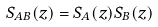<formula> <loc_0><loc_0><loc_500><loc_500>S _ { A B } ( z ) = S _ { A } ( z ) S _ { B } ( z )</formula> 